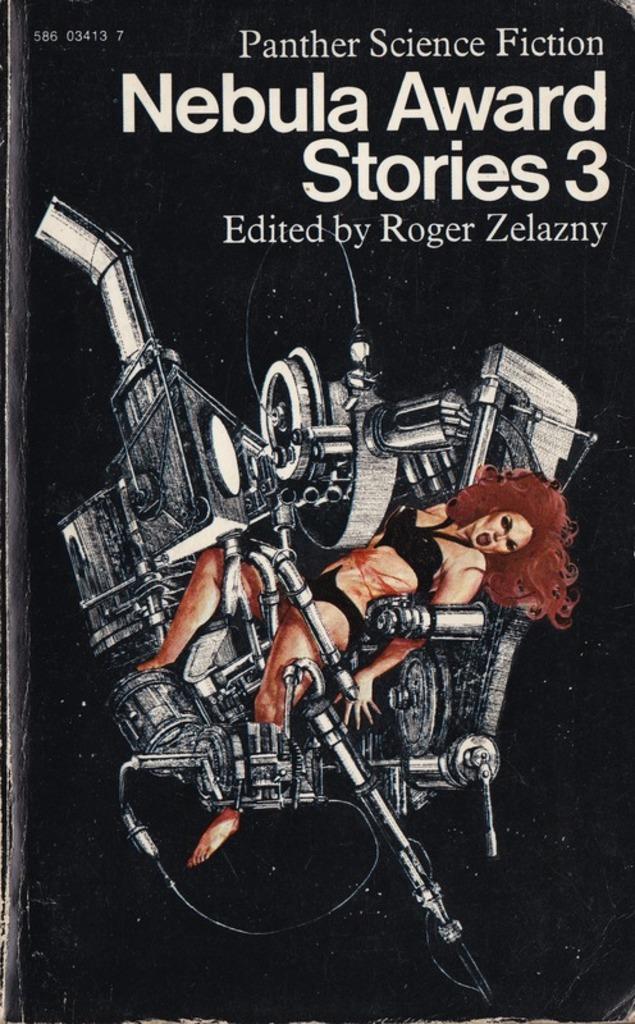What type of science fiction is this?
Offer a terse response. Panther. Who was this edited by?
Make the answer very short. Roger zelazny. 